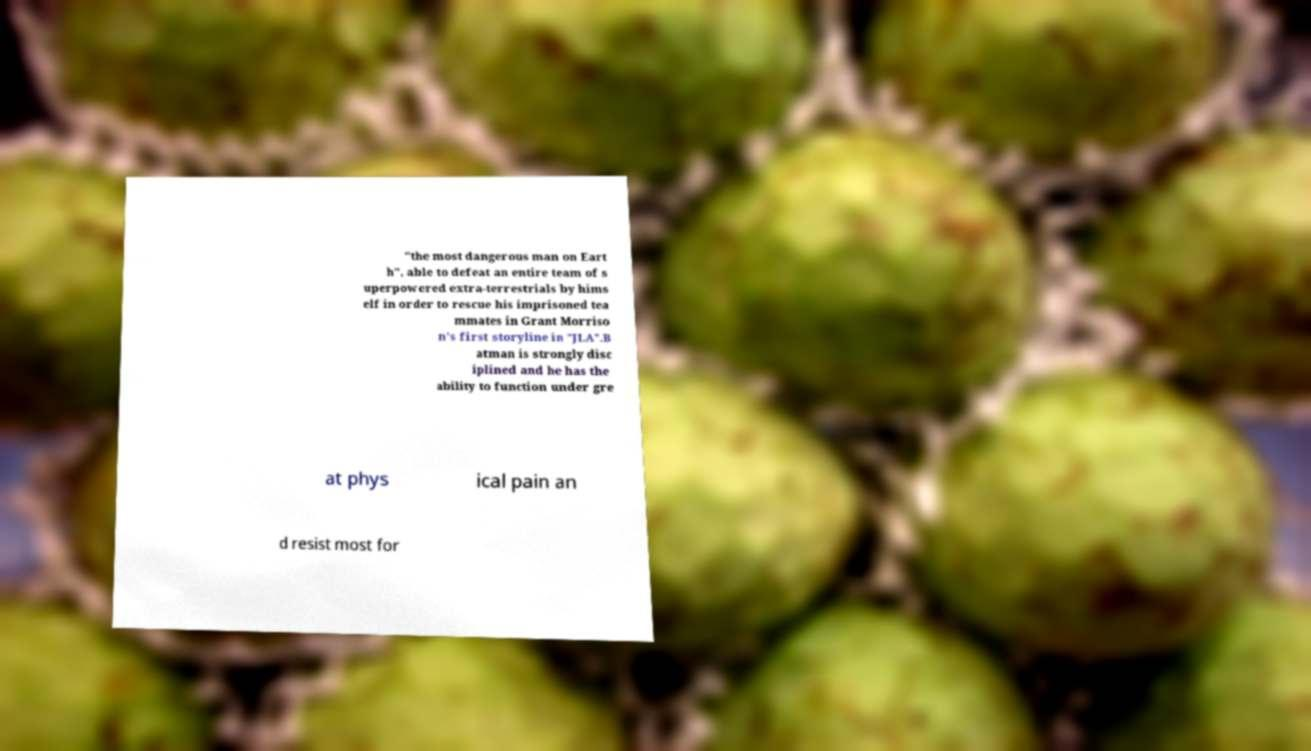Please read and relay the text visible in this image. What does it say? "the most dangerous man on Eart h", able to defeat an entire team of s uperpowered extra-terrestrials by hims elf in order to rescue his imprisoned tea mmates in Grant Morriso n's first storyline in "JLA".B atman is strongly disc iplined and he has the ability to function under gre at phys ical pain an d resist most for 